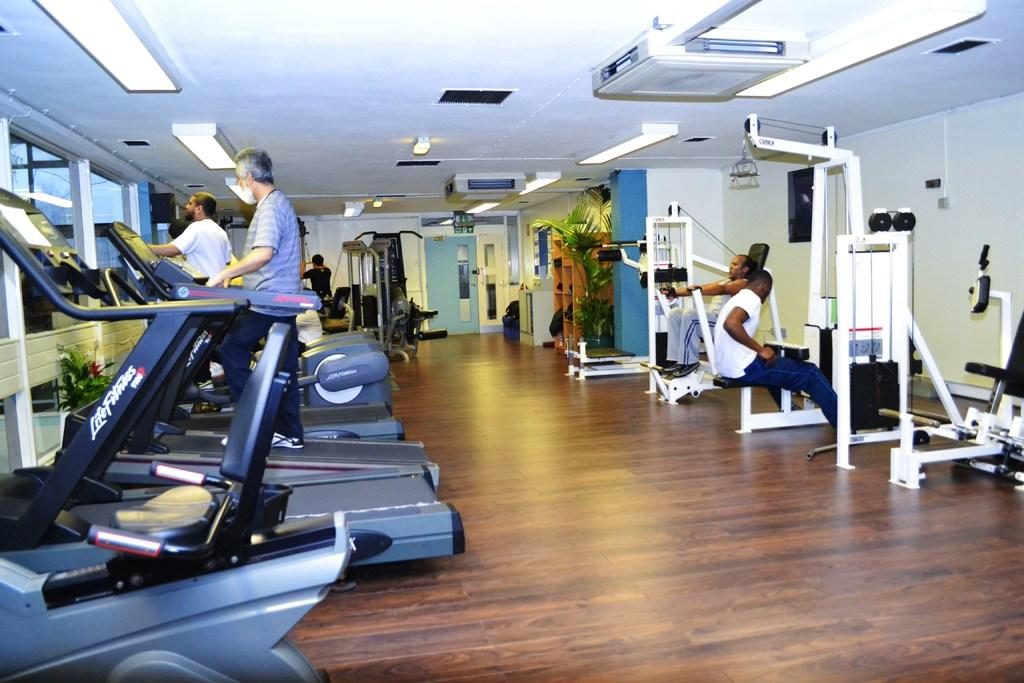What type of location is depicted in the image? The image appears to depict a gym. What can be seen in the gym besides people? There are different exercise equipment in the image. What are the people in the image doing? People are using the equipment for exercises. Is there any greenery visible in the image? Yes, there is a plant on the right side of the image. How many bags can be seen on the office desk in the image? There is no office desk or bags present in the image; it depicts a gym with exercise equipment and people exercising. 